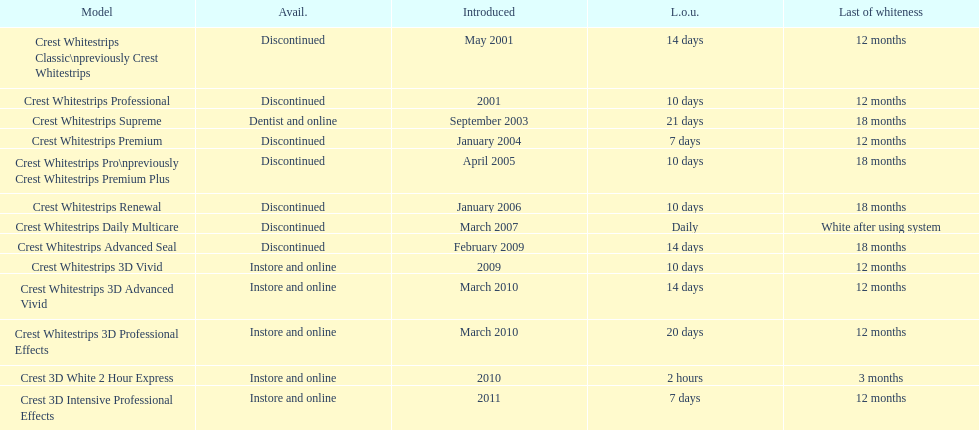Is every white strip terminated? No. 